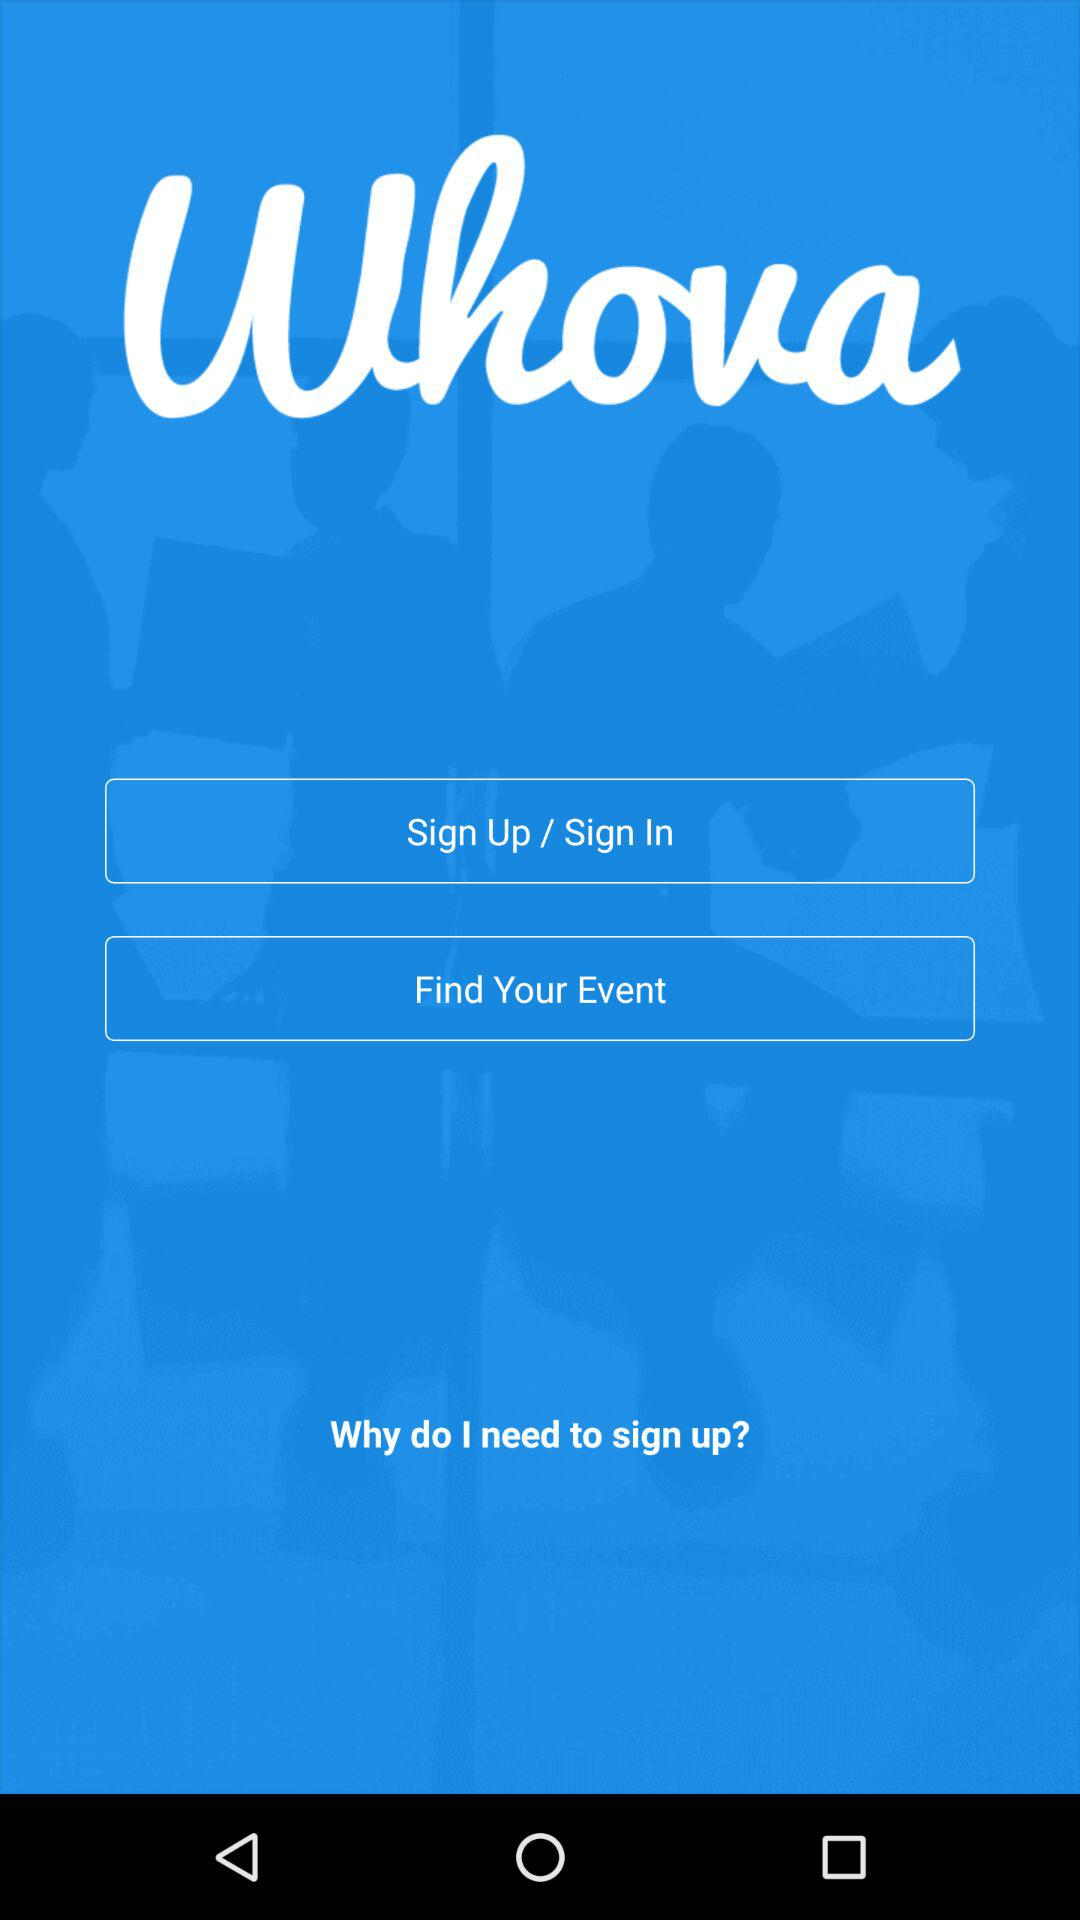What is the application name? The application name is "Whova". 